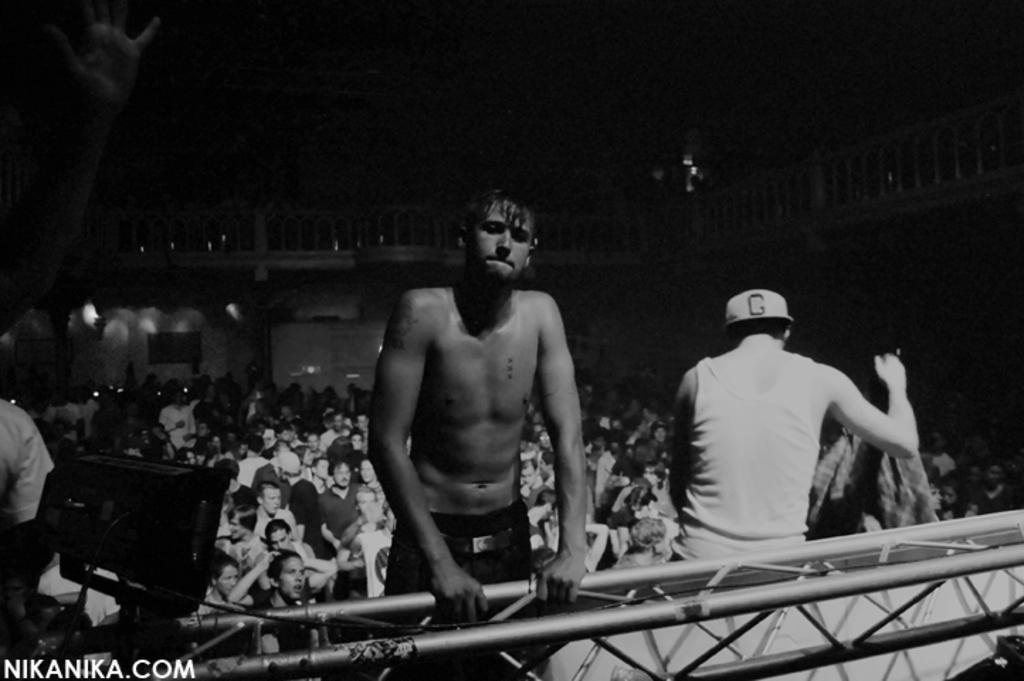Describe this image in one or two sentences. This is a black and white picture, there is a man without shirt standing in the front holding metal rod and behind there are many people standing all over the place. 